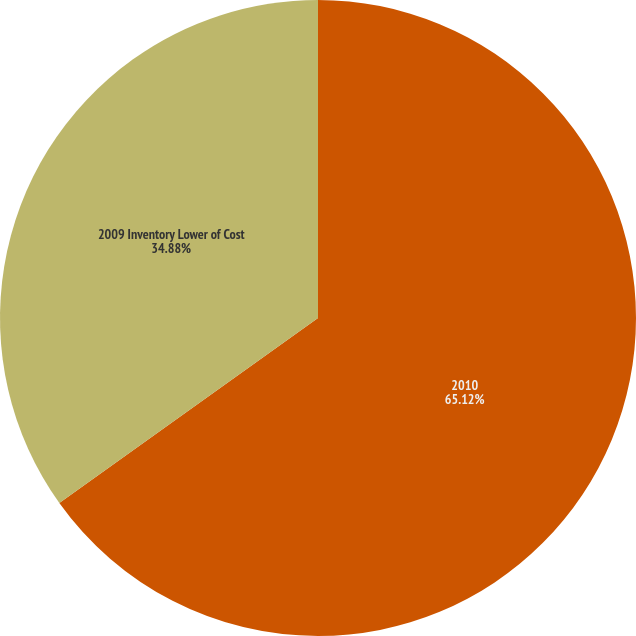Convert chart to OTSL. <chart><loc_0><loc_0><loc_500><loc_500><pie_chart><fcel>2010<fcel>2009 Inventory Lower of Cost<nl><fcel>65.12%<fcel>34.88%<nl></chart> 